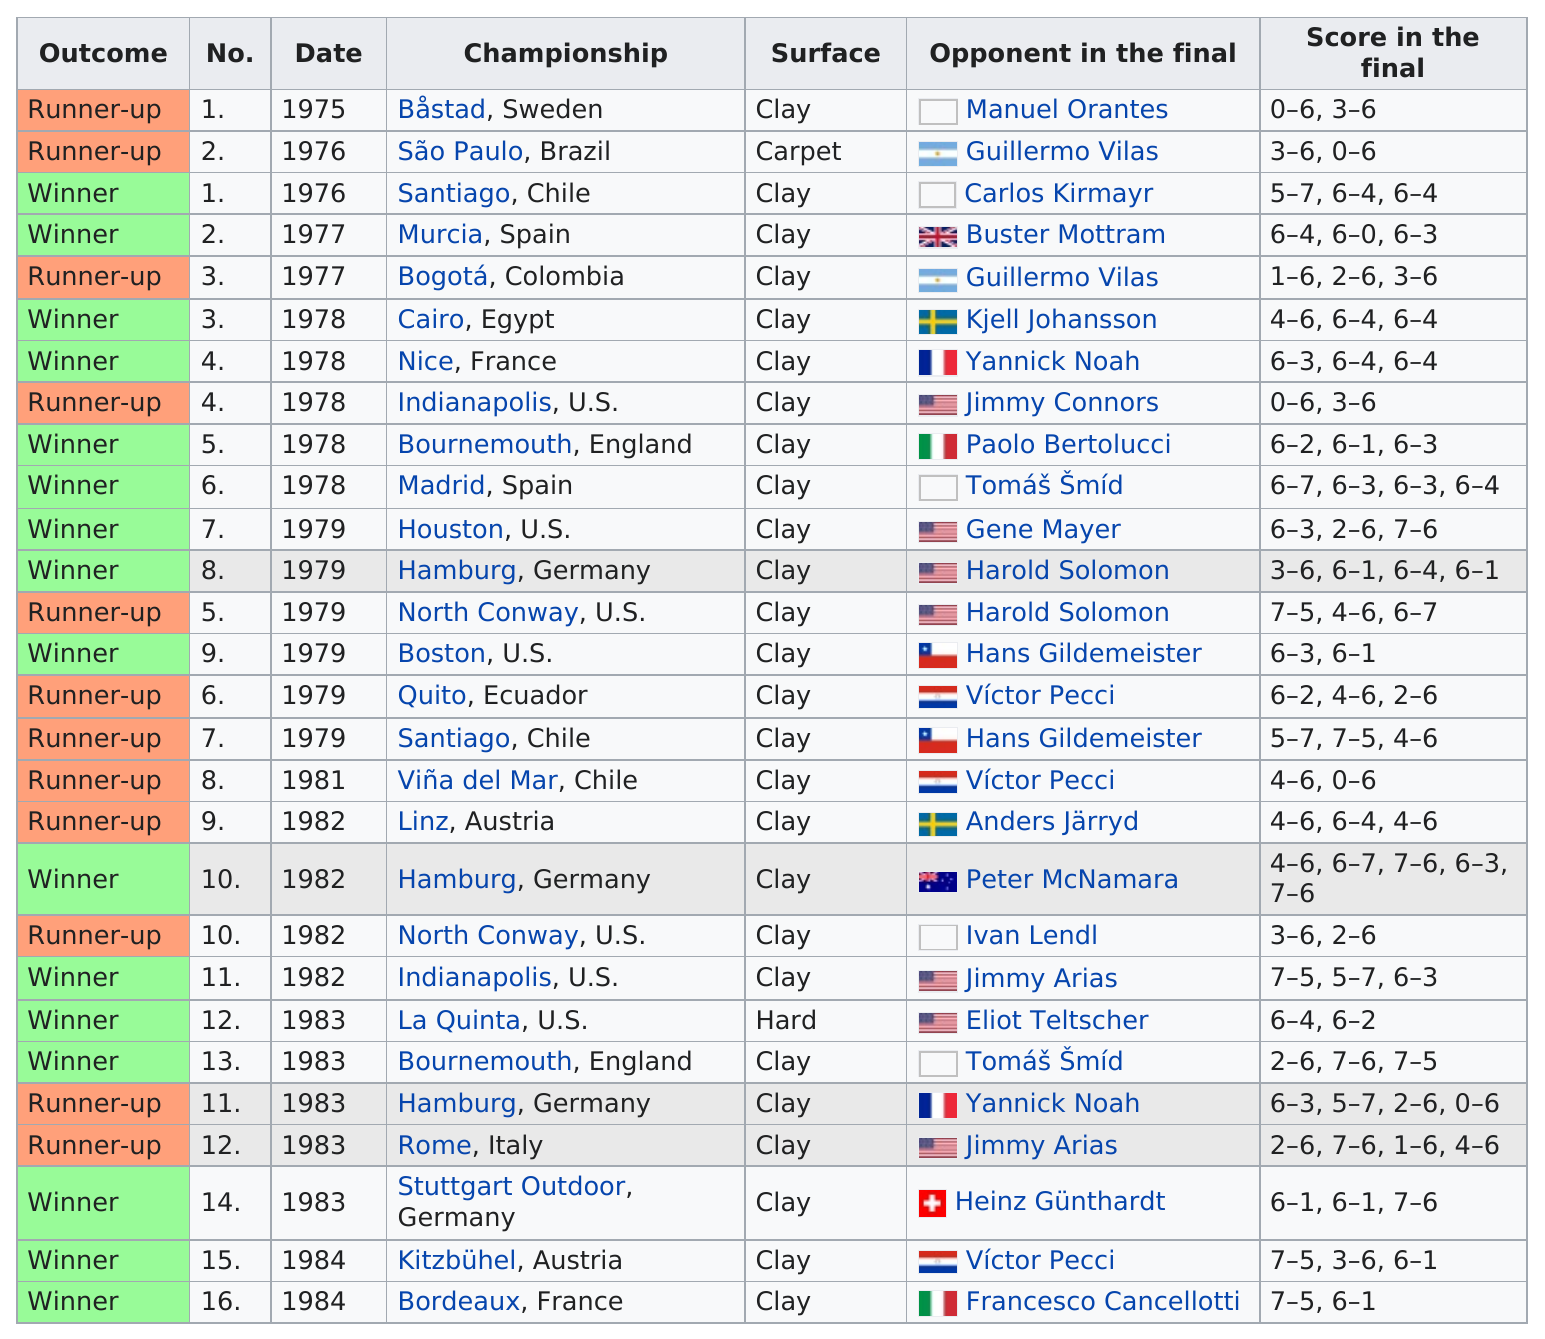Outline some significant characteristics in this image. There are 26 courts that are clay. The total number of games played in the United States is 7.. He won his first title in 1976. The subject won his most recent championship in Bordeaux, France. The Båstad Championship, which only took place in 1975, was held in Båstad, Sweden. 